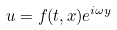Convert formula to latex. <formula><loc_0><loc_0><loc_500><loc_500>u = f ( t , x ) e ^ { i \omega y }</formula> 